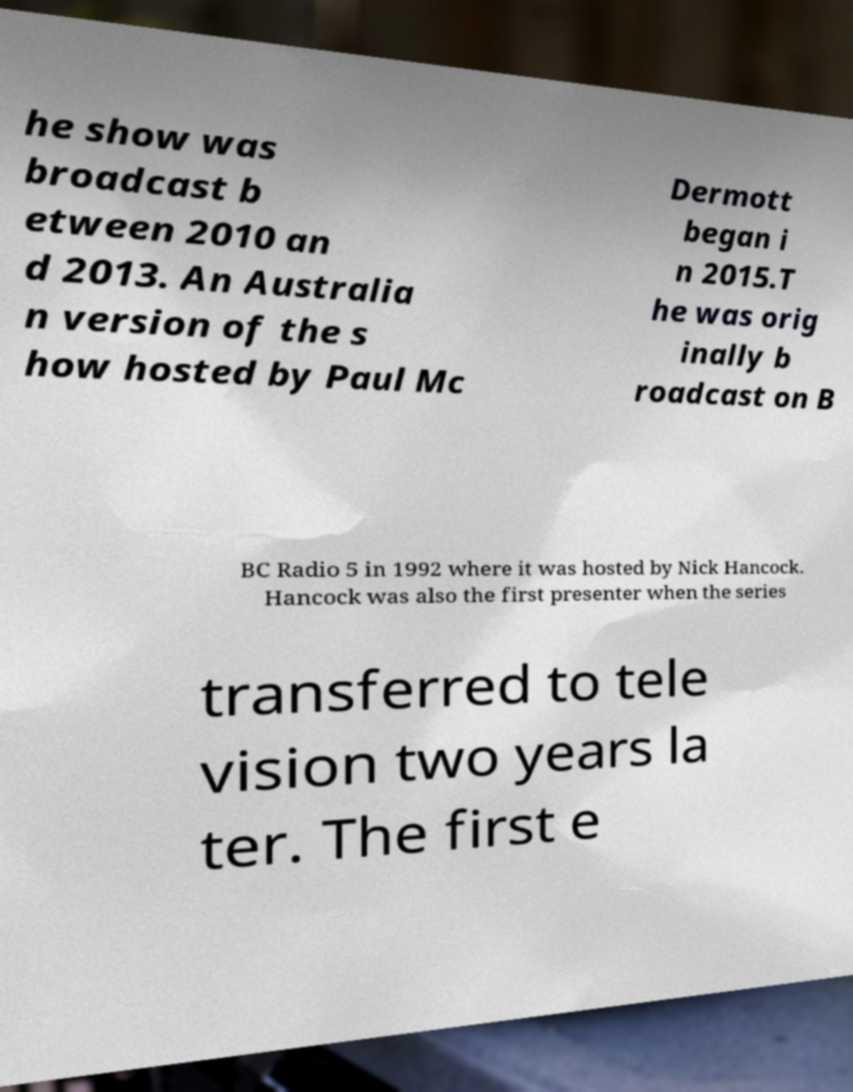Can you accurately transcribe the text from the provided image for me? he show was broadcast b etween 2010 an d 2013. An Australia n version of the s how hosted by Paul Mc Dermott began i n 2015.T he was orig inally b roadcast on B BC Radio 5 in 1992 where it was hosted by Nick Hancock. Hancock was also the first presenter when the series transferred to tele vision two years la ter. The first e 